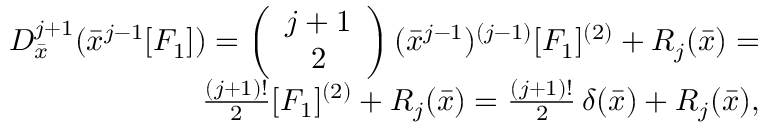<formula> <loc_0><loc_0><loc_500><loc_500>\begin{array} { r l r } & { D _ { \bar { x } } ^ { j + 1 } ( { \bar { x } } ^ { j - 1 } [ F _ { 1 } ] ) = \left ( \begin{array} { c } { j + 1 } \\ { 2 } \end{array} \right ) ( { \bar { x } } ^ { j - 1 } ) ^ { ( j - 1 ) } [ F _ { 1 } ] ^ { ( 2 ) } + R _ { j } ( { \bar { x } } ) = } \\ & { \frac { ( j + 1 ) ! } { 2 } [ F _ { 1 } ] ^ { ( 2 ) } + R _ { j } ( { \bar { x } } ) = \frac { ( j + 1 ) ! } { 2 } \, \delta ( { \bar { x } } ) + R _ { j } ( { \bar { x } } ) , } \end{array}</formula> 